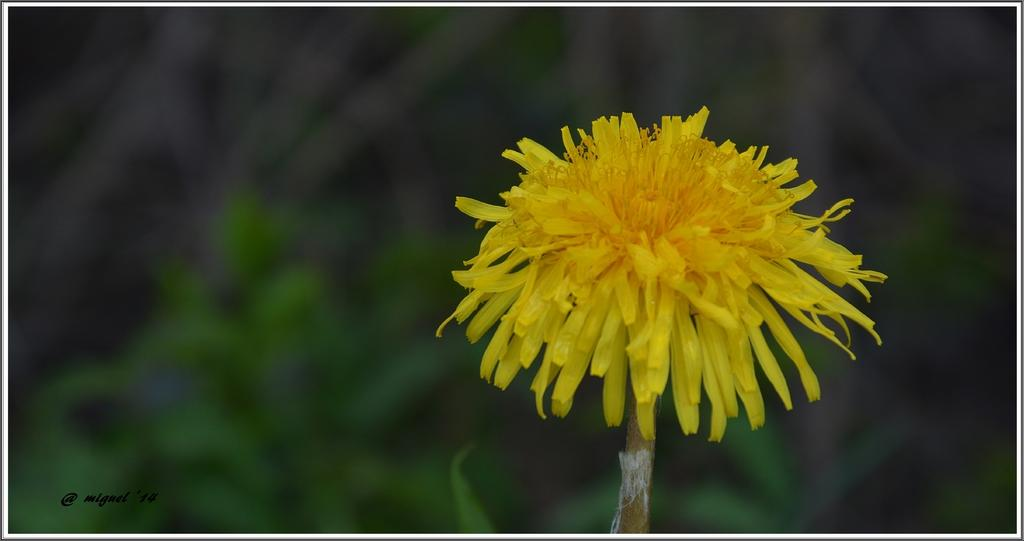What color is the flower in the image? The flower in the image is yellow. Where is the yellow flower located in the image? The yellow flower is on the right side of the image. Can you describe the background of the image? The background of the image is blurred. What type of cheese is visible under the veil in the image? There is no cheese or veil present in the image; it features a yellow flower on the right side with a blurred background. 